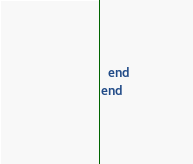Convert code to text. <code><loc_0><loc_0><loc_500><loc_500><_Ruby_>  end
end

</code> 